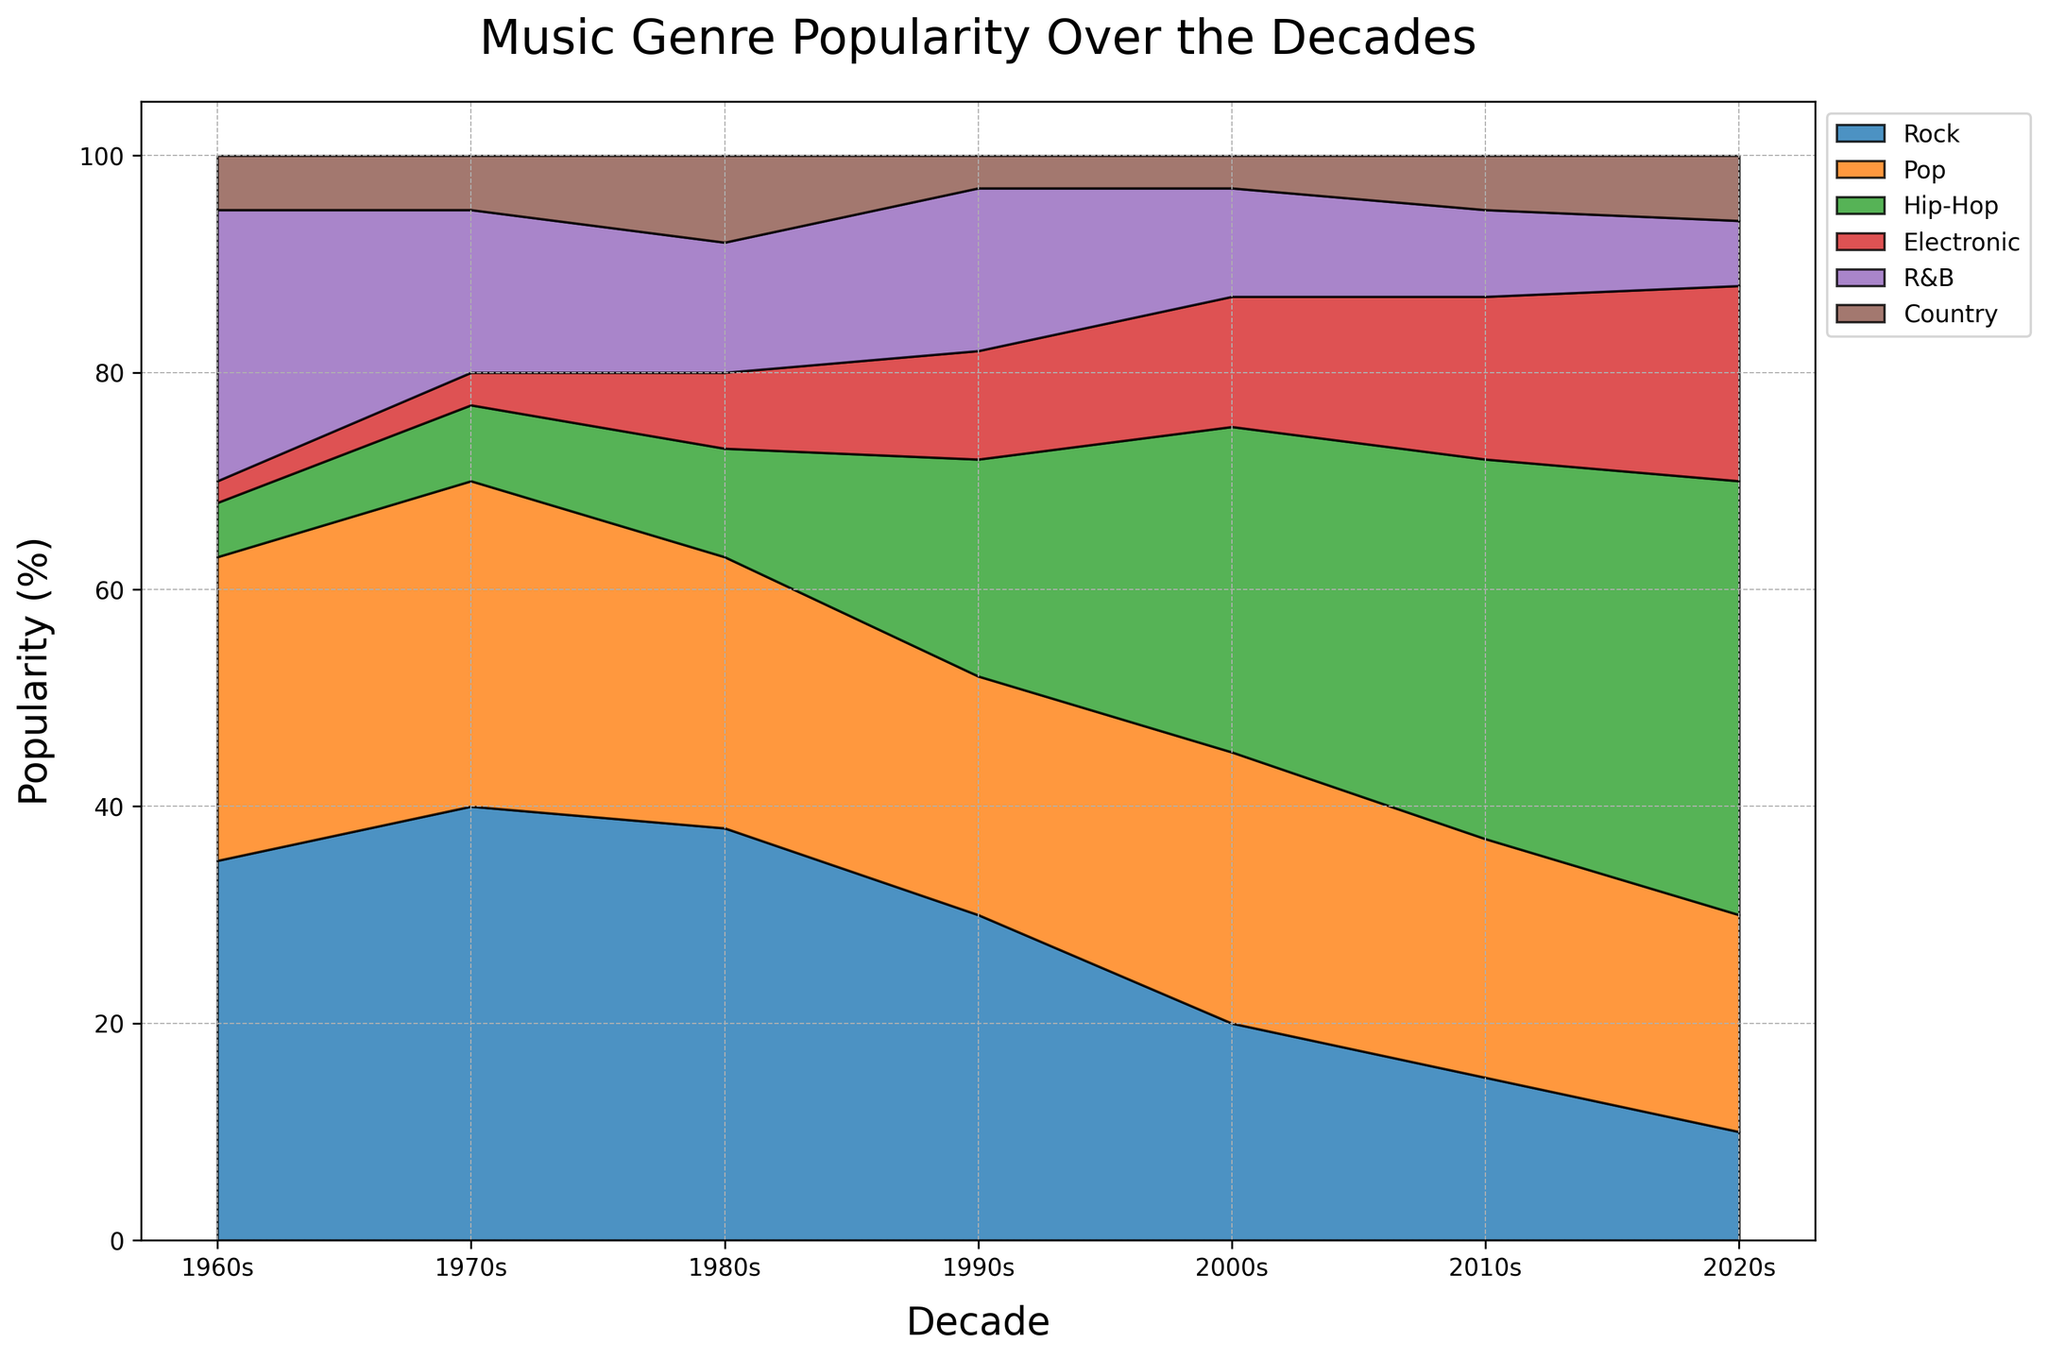Which decade had the highest overall popularity for Rock music? Look at the area corresponding to Rock music. The height of the area is highest in the 1970s.
Answer: 1970s In which decade did Hip-Hop first appear in the data, and what was its initial popularity percentage? Look through the decades for the first appearance of Hip-Hop music. It first appears in the 1960s with a popularity of 5%.
Answer: 1960s, 5% By how much did the popularity of Electronic music increase from the 1980s to the 2010s? Compare the percentage of Electronic music in the 1980s (7%) and the 2010s (15%). Subtract the former from the latter (15% - 7%).
Answer: 8% Between the 80s and 90s, which music genre saw the greatest increase in popularity, and by how much? Compare the percentage of each genre in the 1980s and 1990s. The largest increase is in Hip-Hop from 10% to 20%, an increase of 10%.
Answer: Hip-Hop, 10% From the 1980s to the 1990s, which genre showed a decrease in popularity, and what was the magnitude of the decrease? Compare the popularity percentages of genres in the 1980s and 1990s. Rock shows a decrease from 38% to 30%, which is a decrease of 8%.
Answer: Rock, 8% How did the combined popularity of Rock and Pop change from the 80s to the 90s? Sum the percentages of Rock and Pop for both decades: 80s (38 + 25 = 63) and 90s (30 + 22 = 52). The combined change is 63% - 52% = 11%.
Answer: Decreased by 11% By how many percentage points did the popularity of Country music change from the 1980s to the 1990s? Compare the Country music percentages in the 1980s (8%) and 1990s (3%). Subtract the latter from the former (8% - 3%).
Answer: Decreased by 5% Which genre had the smallest change in popularity between the 80s and 90s, and what was the change? Look for the genre with the smallest absolute percentage difference between the 80s and 90s. R&B changed from 12% in the 80s to 15% in the 90s, a change of 3%.
Answer: R&B, 3% In the 1980s, what was the total combined percentage popularity of R&B and Electronic music? Add the percentages of R&B and Electronic music in the 1980s (12% + 7%).
Answer: 19% During which decade did Pop music have its second highest popularity, and what was the percentage? Check each decade's Pop percentages, the highest is 2000s (25%) and second highest is 1970s (30%).
Answer: 1970s, 30% 